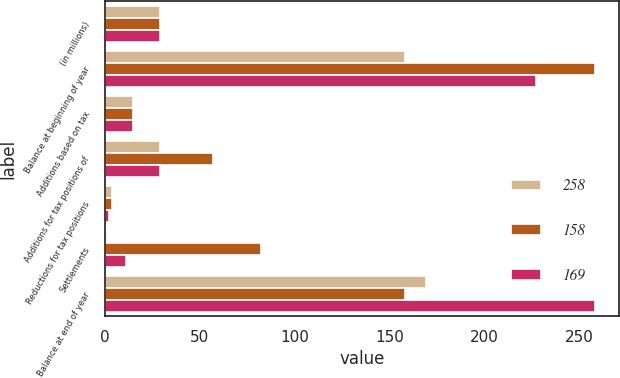Convert chart. <chart><loc_0><loc_0><loc_500><loc_500><stacked_bar_chart><ecel><fcel>(in millions)<fcel>Balance at beginning of year<fcel>Additions based on tax<fcel>Additions for tax positions of<fcel>Reductions for tax positions<fcel>Settlements<fcel>Balance at end of year<nl><fcel>258<fcel>29<fcel>158<fcel>15<fcel>29<fcel>4<fcel>1<fcel>169<nl><fcel>158<fcel>29<fcel>258<fcel>15<fcel>57<fcel>4<fcel>82<fcel>158<nl><fcel>169<fcel>29<fcel>227<fcel>15<fcel>29<fcel>2<fcel>11<fcel>258<nl></chart> 